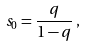Convert formula to latex. <formula><loc_0><loc_0><loc_500><loc_500>s _ { 0 } = \frac { q } { 1 - q } \, ,</formula> 